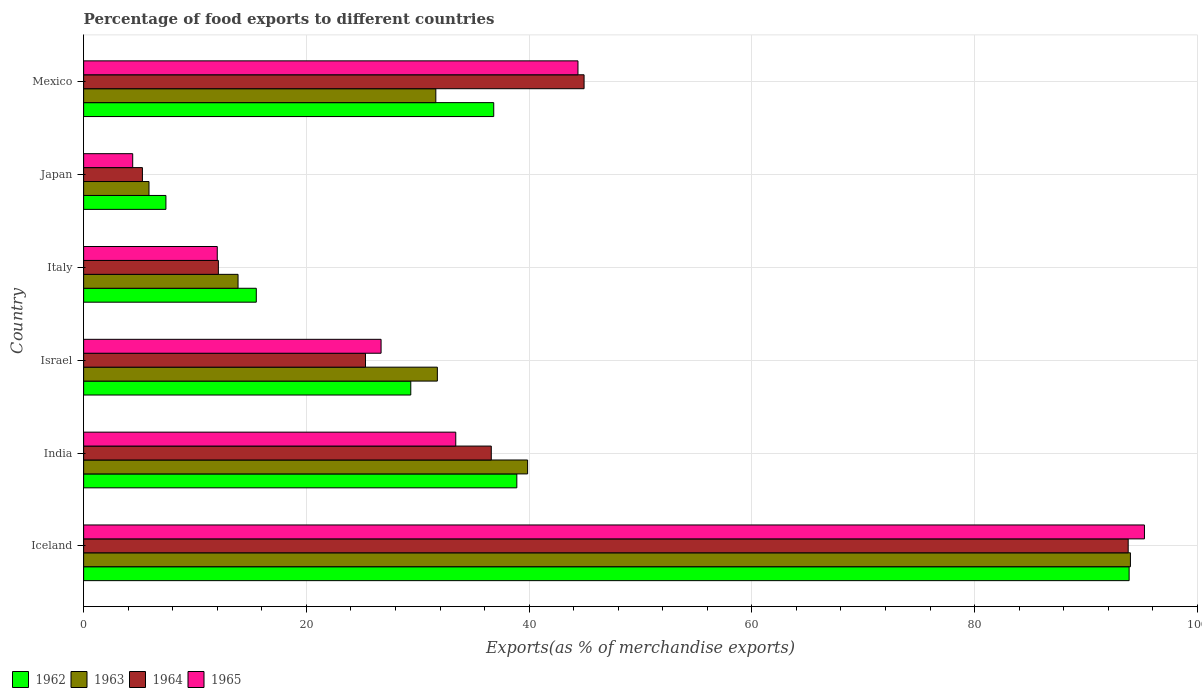How many different coloured bars are there?
Offer a terse response. 4. Are the number of bars per tick equal to the number of legend labels?
Provide a succinct answer. Yes. Are the number of bars on each tick of the Y-axis equal?
Offer a very short reply. Yes. How many bars are there on the 1st tick from the bottom?
Ensure brevity in your answer.  4. What is the label of the 3rd group of bars from the top?
Keep it short and to the point. Italy. What is the percentage of exports to different countries in 1965 in Japan?
Offer a terse response. 4.41. Across all countries, what is the maximum percentage of exports to different countries in 1962?
Offer a very short reply. 93.87. Across all countries, what is the minimum percentage of exports to different countries in 1962?
Your answer should be very brief. 7.39. In which country was the percentage of exports to different countries in 1962 maximum?
Ensure brevity in your answer.  Iceland. In which country was the percentage of exports to different countries in 1964 minimum?
Provide a succinct answer. Japan. What is the total percentage of exports to different countries in 1964 in the graph?
Give a very brief answer. 218.01. What is the difference between the percentage of exports to different countries in 1964 in Iceland and that in Mexico?
Provide a short and direct response. 48.86. What is the difference between the percentage of exports to different countries in 1964 in India and the percentage of exports to different countries in 1963 in Mexico?
Your response must be concise. 4.98. What is the average percentage of exports to different countries in 1963 per country?
Provide a succinct answer. 36.16. What is the difference between the percentage of exports to different countries in 1965 and percentage of exports to different countries in 1963 in Italy?
Your answer should be very brief. -1.87. What is the ratio of the percentage of exports to different countries in 1963 in India to that in Italy?
Provide a succinct answer. 2.88. Is the percentage of exports to different countries in 1962 in India less than that in Italy?
Give a very brief answer. No. Is the difference between the percentage of exports to different countries in 1965 in Italy and Japan greater than the difference between the percentage of exports to different countries in 1963 in Italy and Japan?
Ensure brevity in your answer.  No. What is the difference between the highest and the second highest percentage of exports to different countries in 1963?
Make the answer very short. 54.13. What is the difference between the highest and the lowest percentage of exports to different countries in 1963?
Keep it short and to the point. 88.12. What does the 4th bar from the top in Italy represents?
Provide a succinct answer. 1962. What does the 1st bar from the bottom in India represents?
Your answer should be compact. 1962. How many bars are there?
Keep it short and to the point. 24. Are all the bars in the graph horizontal?
Give a very brief answer. Yes. What is the difference between two consecutive major ticks on the X-axis?
Your response must be concise. 20. Are the values on the major ticks of X-axis written in scientific E-notation?
Provide a succinct answer. No. Where does the legend appear in the graph?
Ensure brevity in your answer.  Bottom left. What is the title of the graph?
Keep it short and to the point. Percentage of food exports to different countries. What is the label or title of the X-axis?
Make the answer very short. Exports(as % of merchandise exports). What is the Exports(as % of merchandise exports) of 1962 in Iceland?
Make the answer very short. 93.87. What is the Exports(as % of merchandise exports) in 1963 in Iceland?
Provide a succinct answer. 93.99. What is the Exports(as % of merchandise exports) in 1964 in Iceland?
Make the answer very short. 93.79. What is the Exports(as % of merchandise exports) in 1965 in Iceland?
Provide a succinct answer. 95.25. What is the Exports(as % of merchandise exports) of 1962 in India?
Provide a succinct answer. 38.9. What is the Exports(as % of merchandise exports) in 1963 in India?
Your answer should be very brief. 39.86. What is the Exports(as % of merchandise exports) in 1964 in India?
Keep it short and to the point. 36.6. What is the Exports(as % of merchandise exports) of 1965 in India?
Offer a terse response. 33.41. What is the Exports(as % of merchandise exports) in 1962 in Israel?
Offer a very short reply. 29.37. What is the Exports(as % of merchandise exports) of 1963 in Israel?
Your answer should be compact. 31.76. What is the Exports(as % of merchandise exports) in 1964 in Israel?
Provide a succinct answer. 25.31. What is the Exports(as % of merchandise exports) of 1965 in Israel?
Provide a short and direct response. 26.71. What is the Exports(as % of merchandise exports) of 1962 in Italy?
Make the answer very short. 15.5. What is the Exports(as % of merchandise exports) in 1963 in Italy?
Provide a short and direct response. 13.86. What is the Exports(as % of merchandise exports) in 1964 in Italy?
Keep it short and to the point. 12.1. What is the Exports(as % of merchandise exports) of 1965 in Italy?
Offer a very short reply. 12. What is the Exports(as % of merchandise exports) of 1962 in Japan?
Your answer should be very brief. 7.39. What is the Exports(as % of merchandise exports) of 1963 in Japan?
Your response must be concise. 5.87. What is the Exports(as % of merchandise exports) of 1964 in Japan?
Offer a very short reply. 5.28. What is the Exports(as % of merchandise exports) of 1965 in Japan?
Make the answer very short. 4.41. What is the Exports(as % of merchandise exports) of 1962 in Mexico?
Make the answer very short. 36.82. What is the Exports(as % of merchandise exports) of 1963 in Mexico?
Your answer should be very brief. 31.62. What is the Exports(as % of merchandise exports) in 1964 in Mexico?
Provide a short and direct response. 44.93. What is the Exports(as % of merchandise exports) of 1965 in Mexico?
Give a very brief answer. 44.39. Across all countries, what is the maximum Exports(as % of merchandise exports) in 1962?
Your answer should be very brief. 93.87. Across all countries, what is the maximum Exports(as % of merchandise exports) of 1963?
Provide a short and direct response. 93.99. Across all countries, what is the maximum Exports(as % of merchandise exports) in 1964?
Make the answer very short. 93.79. Across all countries, what is the maximum Exports(as % of merchandise exports) of 1965?
Your answer should be compact. 95.25. Across all countries, what is the minimum Exports(as % of merchandise exports) in 1962?
Your answer should be very brief. 7.39. Across all countries, what is the minimum Exports(as % of merchandise exports) in 1963?
Provide a short and direct response. 5.87. Across all countries, what is the minimum Exports(as % of merchandise exports) of 1964?
Your answer should be compact. 5.28. Across all countries, what is the minimum Exports(as % of merchandise exports) in 1965?
Provide a succinct answer. 4.41. What is the total Exports(as % of merchandise exports) in 1962 in the graph?
Ensure brevity in your answer.  221.86. What is the total Exports(as % of merchandise exports) in 1963 in the graph?
Offer a terse response. 216.97. What is the total Exports(as % of merchandise exports) in 1964 in the graph?
Offer a terse response. 218.01. What is the total Exports(as % of merchandise exports) of 1965 in the graph?
Provide a succinct answer. 216.16. What is the difference between the Exports(as % of merchandise exports) of 1962 in Iceland and that in India?
Your response must be concise. 54.98. What is the difference between the Exports(as % of merchandise exports) of 1963 in Iceland and that in India?
Your answer should be compact. 54.13. What is the difference between the Exports(as % of merchandise exports) of 1964 in Iceland and that in India?
Offer a terse response. 57.19. What is the difference between the Exports(as % of merchandise exports) of 1965 in Iceland and that in India?
Provide a succinct answer. 61.84. What is the difference between the Exports(as % of merchandise exports) of 1962 in Iceland and that in Israel?
Keep it short and to the point. 64.5. What is the difference between the Exports(as % of merchandise exports) of 1963 in Iceland and that in Israel?
Give a very brief answer. 62.23. What is the difference between the Exports(as % of merchandise exports) in 1964 in Iceland and that in Israel?
Keep it short and to the point. 68.48. What is the difference between the Exports(as % of merchandise exports) of 1965 in Iceland and that in Israel?
Your answer should be compact. 68.54. What is the difference between the Exports(as % of merchandise exports) in 1962 in Iceland and that in Italy?
Give a very brief answer. 78.37. What is the difference between the Exports(as % of merchandise exports) in 1963 in Iceland and that in Italy?
Give a very brief answer. 80.13. What is the difference between the Exports(as % of merchandise exports) in 1964 in Iceland and that in Italy?
Offer a terse response. 81.69. What is the difference between the Exports(as % of merchandise exports) of 1965 in Iceland and that in Italy?
Keep it short and to the point. 83.25. What is the difference between the Exports(as % of merchandise exports) in 1962 in Iceland and that in Japan?
Offer a very short reply. 86.49. What is the difference between the Exports(as % of merchandise exports) in 1963 in Iceland and that in Japan?
Offer a very short reply. 88.12. What is the difference between the Exports(as % of merchandise exports) of 1964 in Iceland and that in Japan?
Give a very brief answer. 88.51. What is the difference between the Exports(as % of merchandise exports) in 1965 in Iceland and that in Japan?
Ensure brevity in your answer.  90.84. What is the difference between the Exports(as % of merchandise exports) in 1962 in Iceland and that in Mexico?
Offer a terse response. 57.05. What is the difference between the Exports(as % of merchandise exports) in 1963 in Iceland and that in Mexico?
Keep it short and to the point. 62.37. What is the difference between the Exports(as % of merchandise exports) of 1964 in Iceland and that in Mexico?
Your answer should be compact. 48.86. What is the difference between the Exports(as % of merchandise exports) of 1965 in Iceland and that in Mexico?
Provide a short and direct response. 50.86. What is the difference between the Exports(as % of merchandise exports) in 1962 in India and that in Israel?
Provide a succinct answer. 9.52. What is the difference between the Exports(as % of merchandise exports) in 1963 in India and that in Israel?
Make the answer very short. 8.1. What is the difference between the Exports(as % of merchandise exports) of 1964 in India and that in Israel?
Ensure brevity in your answer.  11.29. What is the difference between the Exports(as % of merchandise exports) of 1965 in India and that in Israel?
Your answer should be very brief. 6.71. What is the difference between the Exports(as % of merchandise exports) of 1962 in India and that in Italy?
Your answer should be compact. 23.39. What is the difference between the Exports(as % of merchandise exports) in 1963 in India and that in Italy?
Your response must be concise. 26. What is the difference between the Exports(as % of merchandise exports) in 1964 in India and that in Italy?
Your answer should be compact. 24.5. What is the difference between the Exports(as % of merchandise exports) in 1965 in India and that in Italy?
Make the answer very short. 21.41. What is the difference between the Exports(as % of merchandise exports) of 1962 in India and that in Japan?
Ensure brevity in your answer.  31.51. What is the difference between the Exports(as % of merchandise exports) in 1963 in India and that in Japan?
Ensure brevity in your answer.  34. What is the difference between the Exports(as % of merchandise exports) in 1964 in India and that in Japan?
Provide a short and direct response. 31.32. What is the difference between the Exports(as % of merchandise exports) of 1965 in India and that in Japan?
Keep it short and to the point. 29.01. What is the difference between the Exports(as % of merchandise exports) of 1962 in India and that in Mexico?
Ensure brevity in your answer.  2.07. What is the difference between the Exports(as % of merchandise exports) in 1963 in India and that in Mexico?
Your answer should be compact. 8.24. What is the difference between the Exports(as % of merchandise exports) in 1964 in India and that in Mexico?
Your response must be concise. -8.33. What is the difference between the Exports(as % of merchandise exports) in 1965 in India and that in Mexico?
Make the answer very short. -10.97. What is the difference between the Exports(as % of merchandise exports) in 1962 in Israel and that in Italy?
Provide a short and direct response. 13.87. What is the difference between the Exports(as % of merchandise exports) in 1963 in Israel and that in Italy?
Your answer should be compact. 17.9. What is the difference between the Exports(as % of merchandise exports) of 1964 in Israel and that in Italy?
Provide a short and direct response. 13.21. What is the difference between the Exports(as % of merchandise exports) of 1965 in Israel and that in Italy?
Provide a succinct answer. 14.71. What is the difference between the Exports(as % of merchandise exports) in 1962 in Israel and that in Japan?
Provide a short and direct response. 21.98. What is the difference between the Exports(as % of merchandise exports) in 1963 in Israel and that in Japan?
Provide a short and direct response. 25.89. What is the difference between the Exports(as % of merchandise exports) in 1964 in Israel and that in Japan?
Ensure brevity in your answer.  20.03. What is the difference between the Exports(as % of merchandise exports) of 1965 in Israel and that in Japan?
Give a very brief answer. 22.3. What is the difference between the Exports(as % of merchandise exports) of 1962 in Israel and that in Mexico?
Give a very brief answer. -7.45. What is the difference between the Exports(as % of merchandise exports) in 1963 in Israel and that in Mexico?
Provide a short and direct response. 0.14. What is the difference between the Exports(as % of merchandise exports) in 1964 in Israel and that in Mexico?
Offer a very short reply. -19.63. What is the difference between the Exports(as % of merchandise exports) of 1965 in Israel and that in Mexico?
Offer a terse response. -17.68. What is the difference between the Exports(as % of merchandise exports) in 1962 in Italy and that in Japan?
Your response must be concise. 8.11. What is the difference between the Exports(as % of merchandise exports) of 1963 in Italy and that in Japan?
Offer a terse response. 8. What is the difference between the Exports(as % of merchandise exports) in 1964 in Italy and that in Japan?
Provide a short and direct response. 6.82. What is the difference between the Exports(as % of merchandise exports) of 1965 in Italy and that in Japan?
Your response must be concise. 7.59. What is the difference between the Exports(as % of merchandise exports) of 1962 in Italy and that in Mexico?
Offer a very short reply. -21.32. What is the difference between the Exports(as % of merchandise exports) of 1963 in Italy and that in Mexico?
Your answer should be very brief. -17.76. What is the difference between the Exports(as % of merchandise exports) in 1964 in Italy and that in Mexico?
Keep it short and to the point. -32.84. What is the difference between the Exports(as % of merchandise exports) in 1965 in Italy and that in Mexico?
Keep it short and to the point. -32.39. What is the difference between the Exports(as % of merchandise exports) in 1962 in Japan and that in Mexico?
Offer a terse response. -29.43. What is the difference between the Exports(as % of merchandise exports) of 1963 in Japan and that in Mexico?
Keep it short and to the point. -25.75. What is the difference between the Exports(as % of merchandise exports) in 1964 in Japan and that in Mexico?
Your response must be concise. -39.66. What is the difference between the Exports(as % of merchandise exports) of 1965 in Japan and that in Mexico?
Provide a short and direct response. -39.98. What is the difference between the Exports(as % of merchandise exports) in 1962 in Iceland and the Exports(as % of merchandise exports) in 1963 in India?
Provide a short and direct response. 54.01. What is the difference between the Exports(as % of merchandise exports) in 1962 in Iceland and the Exports(as % of merchandise exports) in 1964 in India?
Provide a short and direct response. 57.27. What is the difference between the Exports(as % of merchandise exports) in 1962 in Iceland and the Exports(as % of merchandise exports) in 1965 in India?
Provide a short and direct response. 60.46. What is the difference between the Exports(as % of merchandise exports) of 1963 in Iceland and the Exports(as % of merchandise exports) of 1964 in India?
Provide a short and direct response. 57.39. What is the difference between the Exports(as % of merchandise exports) in 1963 in Iceland and the Exports(as % of merchandise exports) in 1965 in India?
Keep it short and to the point. 60.58. What is the difference between the Exports(as % of merchandise exports) of 1964 in Iceland and the Exports(as % of merchandise exports) of 1965 in India?
Give a very brief answer. 60.38. What is the difference between the Exports(as % of merchandise exports) in 1962 in Iceland and the Exports(as % of merchandise exports) in 1963 in Israel?
Offer a very short reply. 62.11. What is the difference between the Exports(as % of merchandise exports) in 1962 in Iceland and the Exports(as % of merchandise exports) in 1964 in Israel?
Your response must be concise. 68.57. What is the difference between the Exports(as % of merchandise exports) in 1962 in Iceland and the Exports(as % of merchandise exports) in 1965 in Israel?
Your answer should be very brief. 67.17. What is the difference between the Exports(as % of merchandise exports) of 1963 in Iceland and the Exports(as % of merchandise exports) of 1964 in Israel?
Provide a short and direct response. 68.68. What is the difference between the Exports(as % of merchandise exports) of 1963 in Iceland and the Exports(as % of merchandise exports) of 1965 in Israel?
Make the answer very short. 67.28. What is the difference between the Exports(as % of merchandise exports) in 1964 in Iceland and the Exports(as % of merchandise exports) in 1965 in Israel?
Ensure brevity in your answer.  67.08. What is the difference between the Exports(as % of merchandise exports) in 1962 in Iceland and the Exports(as % of merchandise exports) in 1963 in Italy?
Your answer should be compact. 80.01. What is the difference between the Exports(as % of merchandise exports) in 1962 in Iceland and the Exports(as % of merchandise exports) in 1964 in Italy?
Your response must be concise. 81.78. What is the difference between the Exports(as % of merchandise exports) of 1962 in Iceland and the Exports(as % of merchandise exports) of 1965 in Italy?
Ensure brevity in your answer.  81.88. What is the difference between the Exports(as % of merchandise exports) of 1963 in Iceland and the Exports(as % of merchandise exports) of 1964 in Italy?
Offer a terse response. 81.89. What is the difference between the Exports(as % of merchandise exports) in 1963 in Iceland and the Exports(as % of merchandise exports) in 1965 in Italy?
Provide a short and direct response. 81.99. What is the difference between the Exports(as % of merchandise exports) of 1964 in Iceland and the Exports(as % of merchandise exports) of 1965 in Italy?
Offer a very short reply. 81.79. What is the difference between the Exports(as % of merchandise exports) of 1962 in Iceland and the Exports(as % of merchandise exports) of 1963 in Japan?
Provide a succinct answer. 88.01. What is the difference between the Exports(as % of merchandise exports) in 1962 in Iceland and the Exports(as % of merchandise exports) in 1964 in Japan?
Offer a terse response. 88.6. What is the difference between the Exports(as % of merchandise exports) of 1962 in Iceland and the Exports(as % of merchandise exports) of 1965 in Japan?
Offer a terse response. 89.47. What is the difference between the Exports(as % of merchandise exports) of 1963 in Iceland and the Exports(as % of merchandise exports) of 1964 in Japan?
Ensure brevity in your answer.  88.71. What is the difference between the Exports(as % of merchandise exports) in 1963 in Iceland and the Exports(as % of merchandise exports) in 1965 in Japan?
Offer a very short reply. 89.58. What is the difference between the Exports(as % of merchandise exports) in 1964 in Iceland and the Exports(as % of merchandise exports) in 1965 in Japan?
Provide a short and direct response. 89.38. What is the difference between the Exports(as % of merchandise exports) of 1962 in Iceland and the Exports(as % of merchandise exports) of 1963 in Mexico?
Your response must be concise. 62.25. What is the difference between the Exports(as % of merchandise exports) in 1962 in Iceland and the Exports(as % of merchandise exports) in 1964 in Mexico?
Your response must be concise. 48.94. What is the difference between the Exports(as % of merchandise exports) of 1962 in Iceland and the Exports(as % of merchandise exports) of 1965 in Mexico?
Make the answer very short. 49.49. What is the difference between the Exports(as % of merchandise exports) of 1963 in Iceland and the Exports(as % of merchandise exports) of 1964 in Mexico?
Your answer should be compact. 49.06. What is the difference between the Exports(as % of merchandise exports) in 1963 in Iceland and the Exports(as % of merchandise exports) in 1965 in Mexico?
Your answer should be very brief. 49.6. What is the difference between the Exports(as % of merchandise exports) in 1964 in Iceland and the Exports(as % of merchandise exports) in 1965 in Mexico?
Make the answer very short. 49.4. What is the difference between the Exports(as % of merchandise exports) in 1962 in India and the Exports(as % of merchandise exports) in 1963 in Israel?
Ensure brevity in your answer.  7.14. What is the difference between the Exports(as % of merchandise exports) in 1962 in India and the Exports(as % of merchandise exports) in 1964 in Israel?
Make the answer very short. 13.59. What is the difference between the Exports(as % of merchandise exports) in 1962 in India and the Exports(as % of merchandise exports) in 1965 in Israel?
Your response must be concise. 12.19. What is the difference between the Exports(as % of merchandise exports) in 1963 in India and the Exports(as % of merchandise exports) in 1964 in Israel?
Your response must be concise. 14.56. What is the difference between the Exports(as % of merchandise exports) in 1963 in India and the Exports(as % of merchandise exports) in 1965 in Israel?
Offer a very short reply. 13.16. What is the difference between the Exports(as % of merchandise exports) of 1964 in India and the Exports(as % of merchandise exports) of 1965 in Israel?
Offer a very short reply. 9.89. What is the difference between the Exports(as % of merchandise exports) of 1962 in India and the Exports(as % of merchandise exports) of 1963 in Italy?
Make the answer very short. 25.03. What is the difference between the Exports(as % of merchandise exports) in 1962 in India and the Exports(as % of merchandise exports) in 1964 in Italy?
Offer a very short reply. 26.8. What is the difference between the Exports(as % of merchandise exports) of 1962 in India and the Exports(as % of merchandise exports) of 1965 in Italy?
Provide a short and direct response. 26.9. What is the difference between the Exports(as % of merchandise exports) of 1963 in India and the Exports(as % of merchandise exports) of 1964 in Italy?
Offer a terse response. 27.77. What is the difference between the Exports(as % of merchandise exports) of 1963 in India and the Exports(as % of merchandise exports) of 1965 in Italy?
Your answer should be very brief. 27.87. What is the difference between the Exports(as % of merchandise exports) in 1964 in India and the Exports(as % of merchandise exports) in 1965 in Italy?
Your answer should be compact. 24.6. What is the difference between the Exports(as % of merchandise exports) in 1962 in India and the Exports(as % of merchandise exports) in 1963 in Japan?
Your response must be concise. 33.03. What is the difference between the Exports(as % of merchandise exports) of 1962 in India and the Exports(as % of merchandise exports) of 1964 in Japan?
Your answer should be very brief. 33.62. What is the difference between the Exports(as % of merchandise exports) in 1962 in India and the Exports(as % of merchandise exports) in 1965 in Japan?
Make the answer very short. 34.49. What is the difference between the Exports(as % of merchandise exports) in 1963 in India and the Exports(as % of merchandise exports) in 1964 in Japan?
Offer a very short reply. 34.59. What is the difference between the Exports(as % of merchandise exports) in 1963 in India and the Exports(as % of merchandise exports) in 1965 in Japan?
Provide a short and direct response. 35.46. What is the difference between the Exports(as % of merchandise exports) in 1964 in India and the Exports(as % of merchandise exports) in 1965 in Japan?
Your response must be concise. 32.2. What is the difference between the Exports(as % of merchandise exports) of 1962 in India and the Exports(as % of merchandise exports) of 1963 in Mexico?
Offer a terse response. 7.27. What is the difference between the Exports(as % of merchandise exports) in 1962 in India and the Exports(as % of merchandise exports) in 1964 in Mexico?
Provide a succinct answer. -6.04. What is the difference between the Exports(as % of merchandise exports) in 1962 in India and the Exports(as % of merchandise exports) in 1965 in Mexico?
Provide a short and direct response. -5.49. What is the difference between the Exports(as % of merchandise exports) of 1963 in India and the Exports(as % of merchandise exports) of 1964 in Mexico?
Make the answer very short. -5.07. What is the difference between the Exports(as % of merchandise exports) in 1963 in India and the Exports(as % of merchandise exports) in 1965 in Mexico?
Keep it short and to the point. -4.52. What is the difference between the Exports(as % of merchandise exports) in 1964 in India and the Exports(as % of merchandise exports) in 1965 in Mexico?
Provide a short and direct response. -7.78. What is the difference between the Exports(as % of merchandise exports) in 1962 in Israel and the Exports(as % of merchandise exports) in 1963 in Italy?
Give a very brief answer. 15.51. What is the difference between the Exports(as % of merchandise exports) in 1962 in Israel and the Exports(as % of merchandise exports) in 1964 in Italy?
Your answer should be compact. 17.27. What is the difference between the Exports(as % of merchandise exports) in 1962 in Israel and the Exports(as % of merchandise exports) in 1965 in Italy?
Ensure brevity in your answer.  17.38. What is the difference between the Exports(as % of merchandise exports) of 1963 in Israel and the Exports(as % of merchandise exports) of 1964 in Italy?
Ensure brevity in your answer.  19.66. What is the difference between the Exports(as % of merchandise exports) of 1963 in Israel and the Exports(as % of merchandise exports) of 1965 in Italy?
Make the answer very short. 19.76. What is the difference between the Exports(as % of merchandise exports) of 1964 in Israel and the Exports(as % of merchandise exports) of 1965 in Italy?
Provide a short and direct response. 13.31. What is the difference between the Exports(as % of merchandise exports) of 1962 in Israel and the Exports(as % of merchandise exports) of 1963 in Japan?
Ensure brevity in your answer.  23.51. What is the difference between the Exports(as % of merchandise exports) in 1962 in Israel and the Exports(as % of merchandise exports) in 1964 in Japan?
Your answer should be very brief. 24.1. What is the difference between the Exports(as % of merchandise exports) of 1962 in Israel and the Exports(as % of merchandise exports) of 1965 in Japan?
Your answer should be very brief. 24.97. What is the difference between the Exports(as % of merchandise exports) in 1963 in Israel and the Exports(as % of merchandise exports) in 1964 in Japan?
Offer a terse response. 26.48. What is the difference between the Exports(as % of merchandise exports) of 1963 in Israel and the Exports(as % of merchandise exports) of 1965 in Japan?
Offer a terse response. 27.35. What is the difference between the Exports(as % of merchandise exports) in 1964 in Israel and the Exports(as % of merchandise exports) in 1965 in Japan?
Ensure brevity in your answer.  20.9. What is the difference between the Exports(as % of merchandise exports) in 1962 in Israel and the Exports(as % of merchandise exports) in 1963 in Mexico?
Offer a very short reply. -2.25. What is the difference between the Exports(as % of merchandise exports) of 1962 in Israel and the Exports(as % of merchandise exports) of 1964 in Mexico?
Keep it short and to the point. -15.56. What is the difference between the Exports(as % of merchandise exports) of 1962 in Israel and the Exports(as % of merchandise exports) of 1965 in Mexico?
Offer a terse response. -15.01. What is the difference between the Exports(as % of merchandise exports) of 1963 in Israel and the Exports(as % of merchandise exports) of 1964 in Mexico?
Offer a very short reply. -13.17. What is the difference between the Exports(as % of merchandise exports) of 1963 in Israel and the Exports(as % of merchandise exports) of 1965 in Mexico?
Your answer should be compact. -12.63. What is the difference between the Exports(as % of merchandise exports) in 1964 in Israel and the Exports(as % of merchandise exports) in 1965 in Mexico?
Your response must be concise. -19.08. What is the difference between the Exports(as % of merchandise exports) in 1962 in Italy and the Exports(as % of merchandise exports) in 1963 in Japan?
Provide a short and direct response. 9.63. What is the difference between the Exports(as % of merchandise exports) of 1962 in Italy and the Exports(as % of merchandise exports) of 1964 in Japan?
Your answer should be compact. 10.23. What is the difference between the Exports(as % of merchandise exports) of 1962 in Italy and the Exports(as % of merchandise exports) of 1965 in Japan?
Make the answer very short. 11.1. What is the difference between the Exports(as % of merchandise exports) in 1963 in Italy and the Exports(as % of merchandise exports) in 1964 in Japan?
Your answer should be very brief. 8.59. What is the difference between the Exports(as % of merchandise exports) in 1963 in Italy and the Exports(as % of merchandise exports) in 1965 in Japan?
Your response must be concise. 9.46. What is the difference between the Exports(as % of merchandise exports) in 1964 in Italy and the Exports(as % of merchandise exports) in 1965 in Japan?
Provide a succinct answer. 7.69. What is the difference between the Exports(as % of merchandise exports) in 1962 in Italy and the Exports(as % of merchandise exports) in 1963 in Mexico?
Provide a short and direct response. -16.12. What is the difference between the Exports(as % of merchandise exports) in 1962 in Italy and the Exports(as % of merchandise exports) in 1964 in Mexico?
Your answer should be very brief. -29.43. What is the difference between the Exports(as % of merchandise exports) of 1962 in Italy and the Exports(as % of merchandise exports) of 1965 in Mexico?
Provide a succinct answer. -28.88. What is the difference between the Exports(as % of merchandise exports) in 1963 in Italy and the Exports(as % of merchandise exports) in 1964 in Mexico?
Your answer should be very brief. -31.07. What is the difference between the Exports(as % of merchandise exports) in 1963 in Italy and the Exports(as % of merchandise exports) in 1965 in Mexico?
Offer a very short reply. -30.52. What is the difference between the Exports(as % of merchandise exports) in 1964 in Italy and the Exports(as % of merchandise exports) in 1965 in Mexico?
Provide a succinct answer. -32.29. What is the difference between the Exports(as % of merchandise exports) of 1962 in Japan and the Exports(as % of merchandise exports) of 1963 in Mexico?
Give a very brief answer. -24.23. What is the difference between the Exports(as % of merchandise exports) of 1962 in Japan and the Exports(as % of merchandise exports) of 1964 in Mexico?
Ensure brevity in your answer.  -37.55. What is the difference between the Exports(as % of merchandise exports) of 1962 in Japan and the Exports(as % of merchandise exports) of 1965 in Mexico?
Keep it short and to the point. -37. What is the difference between the Exports(as % of merchandise exports) in 1963 in Japan and the Exports(as % of merchandise exports) in 1964 in Mexico?
Offer a very short reply. -39.07. What is the difference between the Exports(as % of merchandise exports) in 1963 in Japan and the Exports(as % of merchandise exports) in 1965 in Mexico?
Keep it short and to the point. -38.52. What is the difference between the Exports(as % of merchandise exports) in 1964 in Japan and the Exports(as % of merchandise exports) in 1965 in Mexico?
Provide a short and direct response. -39.11. What is the average Exports(as % of merchandise exports) in 1962 per country?
Provide a short and direct response. 36.98. What is the average Exports(as % of merchandise exports) in 1963 per country?
Offer a terse response. 36.16. What is the average Exports(as % of merchandise exports) of 1964 per country?
Offer a very short reply. 36.34. What is the average Exports(as % of merchandise exports) of 1965 per country?
Make the answer very short. 36.03. What is the difference between the Exports(as % of merchandise exports) in 1962 and Exports(as % of merchandise exports) in 1963 in Iceland?
Your answer should be very brief. -0.12. What is the difference between the Exports(as % of merchandise exports) of 1962 and Exports(as % of merchandise exports) of 1964 in Iceland?
Your answer should be very brief. 0.08. What is the difference between the Exports(as % of merchandise exports) in 1962 and Exports(as % of merchandise exports) in 1965 in Iceland?
Make the answer very short. -1.38. What is the difference between the Exports(as % of merchandise exports) of 1963 and Exports(as % of merchandise exports) of 1964 in Iceland?
Your answer should be very brief. 0.2. What is the difference between the Exports(as % of merchandise exports) in 1963 and Exports(as % of merchandise exports) in 1965 in Iceland?
Give a very brief answer. -1.26. What is the difference between the Exports(as % of merchandise exports) in 1964 and Exports(as % of merchandise exports) in 1965 in Iceland?
Your answer should be very brief. -1.46. What is the difference between the Exports(as % of merchandise exports) of 1962 and Exports(as % of merchandise exports) of 1963 in India?
Keep it short and to the point. -0.97. What is the difference between the Exports(as % of merchandise exports) in 1962 and Exports(as % of merchandise exports) in 1964 in India?
Provide a short and direct response. 2.29. What is the difference between the Exports(as % of merchandise exports) in 1962 and Exports(as % of merchandise exports) in 1965 in India?
Offer a terse response. 5.48. What is the difference between the Exports(as % of merchandise exports) of 1963 and Exports(as % of merchandise exports) of 1964 in India?
Offer a very short reply. 3.26. What is the difference between the Exports(as % of merchandise exports) in 1963 and Exports(as % of merchandise exports) in 1965 in India?
Offer a very short reply. 6.45. What is the difference between the Exports(as % of merchandise exports) of 1964 and Exports(as % of merchandise exports) of 1965 in India?
Keep it short and to the point. 3.19. What is the difference between the Exports(as % of merchandise exports) in 1962 and Exports(as % of merchandise exports) in 1963 in Israel?
Provide a short and direct response. -2.39. What is the difference between the Exports(as % of merchandise exports) of 1962 and Exports(as % of merchandise exports) of 1964 in Israel?
Keep it short and to the point. 4.07. What is the difference between the Exports(as % of merchandise exports) of 1962 and Exports(as % of merchandise exports) of 1965 in Israel?
Your answer should be very brief. 2.67. What is the difference between the Exports(as % of merchandise exports) of 1963 and Exports(as % of merchandise exports) of 1964 in Israel?
Give a very brief answer. 6.45. What is the difference between the Exports(as % of merchandise exports) of 1963 and Exports(as % of merchandise exports) of 1965 in Israel?
Provide a succinct answer. 5.05. What is the difference between the Exports(as % of merchandise exports) of 1964 and Exports(as % of merchandise exports) of 1965 in Israel?
Your answer should be very brief. -1.4. What is the difference between the Exports(as % of merchandise exports) of 1962 and Exports(as % of merchandise exports) of 1963 in Italy?
Keep it short and to the point. 1.64. What is the difference between the Exports(as % of merchandise exports) in 1962 and Exports(as % of merchandise exports) in 1964 in Italy?
Offer a very short reply. 3.4. What is the difference between the Exports(as % of merchandise exports) in 1962 and Exports(as % of merchandise exports) in 1965 in Italy?
Ensure brevity in your answer.  3.5. What is the difference between the Exports(as % of merchandise exports) of 1963 and Exports(as % of merchandise exports) of 1964 in Italy?
Keep it short and to the point. 1.77. What is the difference between the Exports(as % of merchandise exports) of 1963 and Exports(as % of merchandise exports) of 1965 in Italy?
Your response must be concise. 1.87. What is the difference between the Exports(as % of merchandise exports) in 1964 and Exports(as % of merchandise exports) in 1965 in Italy?
Your answer should be compact. 0.1. What is the difference between the Exports(as % of merchandise exports) of 1962 and Exports(as % of merchandise exports) of 1963 in Japan?
Provide a succinct answer. 1.52. What is the difference between the Exports(as % of merchandise exports) of 1962 and Exports(as % of merchandise exports) of 1964 in Japan?
Ensure brevity in your answer.  2.11. What is the difference between the Exports(as % of merchandise exports) of 1962 and Exports(as % of merchandise exports) of 1965 in Japan?
Provide a short and direct response. 2.98. What is the difference between the Exports(as % of merchandise exports) in 1963 and Exports(as % of merchandise exports) in 1964 in Japan?
Provide a succinct answer. 0.59. What is the difference between the Exports(as % of merchandise exports) of 1963 and Exports(as % of merchandise exports) of 1965 in Japan?
Your answer should be very brief. 1.46. What is the difference between the Exports(as % of merchandise exports) of 1964 and Exports(as % of merchandise exports) of 1965 in Japan?
Your response must be concise. 0.87. What is the difference between the Exports(as % of merchandise exports) of 1962 and Exports(as % of merchandise exports) of 1963 in Mexico?
Give a very brief answer. 5.2. What is the difference between the Exports(as % of merchandise exports) in 1962 and Exports(as % of merchandise exports) in 1964 in Mexico?
Make the answer very short. -8.11. What is the difference between the Exports(as % of merchandise exports) in 1962 and Exports(as % of merchandise exports) in 1965 in Mexico?
Provide a succinct answer. -7.56. What is the difference between the Exports(as % of merchandise exports) of 1963 and Exports(as % of merchandise exports) of 1964 in Mexico?
Offer a very short reply. -13.31. What is the difference between the Exports(as % of merchandise exports) of 1963 and Exports(as % of merchandise exports) of 1965 in Mexico?
Ensure brevity in your answer.  -12.76. What is the difference between the Exports(as % of merchandise exports) in 1964 and Exports(as % of merchandise exports) in 1965 in Mexico?
Your response must be concise. 0.55. What is the ratio of the Exports(as % of merchandise exports) of 1962 in Iceland to that in India?
Keep it short and to the point. 2.41. What is the ratio of the Exports(as % of merchandise exports) in 1963 in Iceland to that in India?
Ensure brevity in your answer.  2.36. What is the ratio of the Exports(as % of merchandise exports) of 1964 in Iceland to that in India?
Keep it short and to the point. 2.56. What is the ratio of the Exports(as % of merchandise exports) in 1965 in Iceland to that in India?
Ensure brevity in your answer.  2.85. What is the ratio of the Exports(as % of merchandise exports) in 1962 in Iceland to that in Israel?
Make the answer very short. 3.2. What is the ratio of the Exports(as % of merchandise exports) in 1963 in Iceland to that in Israel?
Provide a short and direct response. 2.96. What is the ratio of the Exports(as % of merchandise exports) of 1964 in Iceland to that in Israel?
Provide a short and direct response. 3.71. What is the ratio of the Exports(as % of merchandise exports) in 1965 in Iceland to that in Israel?
Give a very brief answer. 3.57. What is the ratio of the Exports(as % of merchandise exports) in 1962 in Iceland to that in Italy?
Make the answer very short. 6.05. What is the ratio of the Exports(as % of merchandise exports) of 1963 in Iceland to that in Italy?
Your answer should be very brief. 6.78. What is the ratio of the Exports(as % of merchandise exports) in 1964 in Iceland to that in Italy?
Give a very brief answer. 7.75. What is the ratio of the Exports(as % of merchandise exports) of 1965 in Iceland to that in Italy?
Keep it short and to the point. 7.94. What is the ratio of the Exports(as % of merchandise exports) of 1962 in Iceland to that in Japan?
Provide a short and direct response. 12.7. What is the ratio of the Exports(as % of merchandise exports) of 1963 in Iceland to that in Japan?
Give a very brief answer. 16.01. What is the ratio of the Exports(as % of merchandise exports) in 1964 in Iceland to that in Japan?
Offer a very short reply. 17.77. What is the ratio of the Exports(as % of merchandise exports) in 1965 in Iceland to that in Japan?
Your response must be concise. 21.62. What is the ratio of the Exports(as % of merchandise exports) of 1962 in Iceland to that in Mexico?
Offer a terse response. 2.55. What is the ratio of the Exports(as % of merchandise exports) in 1963 in Iceland to that in Mexico?
Your response must be concise. 2.97. What is the ratio of the Exports(as % of merchandise exports) of 1964 in Iceland to that in Mexico?
Offer a very short reply. 2.09. What is the ratio of the Exports(as % of merchandise exports) in 1965 in Iceland to that in Mexico?
Your answer should be compact. 2.15. What is the ratio of the Exports(as % of merchandise exports) of 1962 in India to that in Israel?
Offer a very short reply. 1.32. What is the ratio of the Exports(as % of merchandise exports) of 1963 in India to that in Israel?
Offer a very short reply. 1.26. What is the ratio of the Exports(as % of merchandise exports) in 1964 in India to that in Israel?
Ensure brevity in your answer.  1.45. What is the ratio of the Exports(as % of merchandise exports) of 1965 in India to that in Israel?
Keep it short and to the point. 1.25. What is the ratio of the Exports(as % of merchandise exports) of 1962 in India to that in Italy?
Offer a terse response. 2.51. What is the ratio of the Exports(as % of merchandise exports) of 1963 in India to that in Italy?
Make the answer very short. 2.88. What is the ratio of the Exports(as % of merchandise exports) of 1964 in India to that in Italy?
Your response must be concise. 3.03. What is the ratio of the Exports(as % of merchandise exports) in 1965 in India to that in Italy?
Provide a short and direct response. 2.78. What is the ratio of the Exports(as % of merchandise exports) of 1962 in India to that in Japan?
Your answer should be compact. 5.26. What is the ratio of the Exports(as % of merchandise exports) of 1963 in India to that in Japan?
Ensure brevity in your answer.  6.79. What is the ratio of the Exports(as % of merchandise exports) of 1964 in India to that in Japan?
Provide a short and direct response. 6.93. What is the ratio of the Exports(as % of merchandise exports) in 1965 in India to that in Japan?
Your answer should be compact. 7.58. What is the ratio of the Exports(as % of merchandise exports) of 1962 in India to that in Mexico?
Provide a succinct answer. 1.06. What is the ratio of the Exports(as % of merchandise exports) of 1963 in India to that in Mexico?
Provide a short and direct response. 1.26. What is the ratio of the Exports(as % of merchandise exports) in 1964 in India to that in Mexico?
Provide a succinct answer. 0.81. What is the ratio of the Exports(as % of merchandise exports) in 1965 in India to that in Mexico?
Keep it short and to the point. 0.75. What is the ratio of the Exports(as % of merchandise exports) of 1962 in Israel to that in Italy?
Provide a succinct answer. 1.89. What is the ratio of the Exports(as % of merchandise exports) of 1963 in Israel to that in Italy?
Your answer should be compact. 2.29. What is the ratio of the Exports(as % of merchandise exports) in 1964 in Israel to that in Italy?
Provide a succinct answer. 2.09. What is the ratio of the Exports(as % of merchandise exports) of 1965 in Israel to that in Italy?
Provide a succinct answer. 2.23. What is the ratio of the Exports(as % of merchandise exports) in 1962 in Israel to that in Japan?
Make the answer very short. 3.98. What is the ratio of the Exports(as % of merchandise exports) in 1963 in Israel to that in Japan?
Offer a very short reply. 5.41. What is the ratio of the Exports(as % of merchandise exports) in 1964 in Israel to that in Japan?
Make the answer very short. 4.79. What is the ratio of the Exports(as % of merchandise exports) in 1965 in Israel to that in Japan?
Give a very brief answer. 6.06. What is the ratio of the Exports(as % of merchandise exports) in 1962 in Israel to that in Mexico?
Your answer should be very brief. 0.8. What is the ratio of the Exports(as % of merchandise exports) in 1963 in Israel to that in Mexico?
Your answer should be compact. 1. What is the ratio of the Exports(as % of merchandise exports) in 1964 in Israel to that in Mexico?
Your answer should be compact. 0.56. What is the ratio of the Exports(as % of merchandise exports) of 1965 in Israel to that in Mexico?
Ensure brevity in your answer.  0.6. What is the ratio of the Exports(as % of merchandise exports) of 1962 in Italy to that in Japan?
Your answer should be very brief. 2.1. What is the ratio of the Exports(as % of merchandise exports) of 1963 in Italy to that in Japan?
Make the answer very short. 2.36. What is the ratio of the Exports(as % of merchandise exports) in 1964 in Italy to that in Japan?
Offer a very short reply. 2.29. What is the ratio of the Exports(as % of merchandise exports) of 1965 in Italy to that in Japan?
Give a very brief answer. 2.72. What is the ratio of the Exports(as % of merchandise exports) of 1962 in Italy to that in Mexico?
Keep it short and to the point. 0.42. What is the ratio of the Exports(as % of merchandise exports) of 1963 in Italy to that in Mexico?
Your response must be concise. 0.44. What is the ratio of the Exports(as % of merchandise exports) in 1964 in Italy to that in Mexico?
Provide a succinct answer. 0.27. What is the ratio of the Exports(as % of merchandise exports) of 1965 in Italy to that in Mexico?
Keep it short and to the point. 0.27. What is the ratio of the Exports(as % of merchandise exports) of 1962 in Japan to that in Mexico?
Your answer should be very brief. 0.2. What is the ratio of the Exports(as % of merchandise exports) in 1963 in Japan to that in Mexico?
Provide a short and direct response. 0.19. What is the ratio of the Exports(as % of merchandise exports) in 1964 in Japan to that in Mexico?
Make the answer very short. 0.12. What is the ratio of the Exports(as % of merchandise exports) in 1965 in Japan to that in Mexico?
Offer a terse response. 0.1. What is the difference between the highest and the second highest Exports(as % of merchandise exports) of 1962?
Keep it short and to the point. 54.98. What is the difference between the highest and the second highest Exports(as % of merchandise exports) in 1963?
Make the answer very short. 54.13. What is the difference between the highest and the second highest Exports(as % of merchandise exports) in 1964?
Offer a very short reply. 48.86. What is the difference between the highest and the second highest Exports(as % of merchandise exports) in 1965?
Offer a terse response. 50.86. What is the difference between the highest and the lowest Exports(as % of merchandise exports) in 1962?
Ensure brevity in your answer.  86.49. What is the difference between the highest and the lowest Exports(as % of merchandise exports) of 1963?
Offer a very short reply. 88.12. What is the difference between the highest and the lowest Exports(as % of merchandise exports) of 1964?
Keep it short and to the point. 88.51. What is the difference between the highest and the lowest Exports(as % of merchandise exports) of 1965?
Keep it short and to the point. 90.84. 